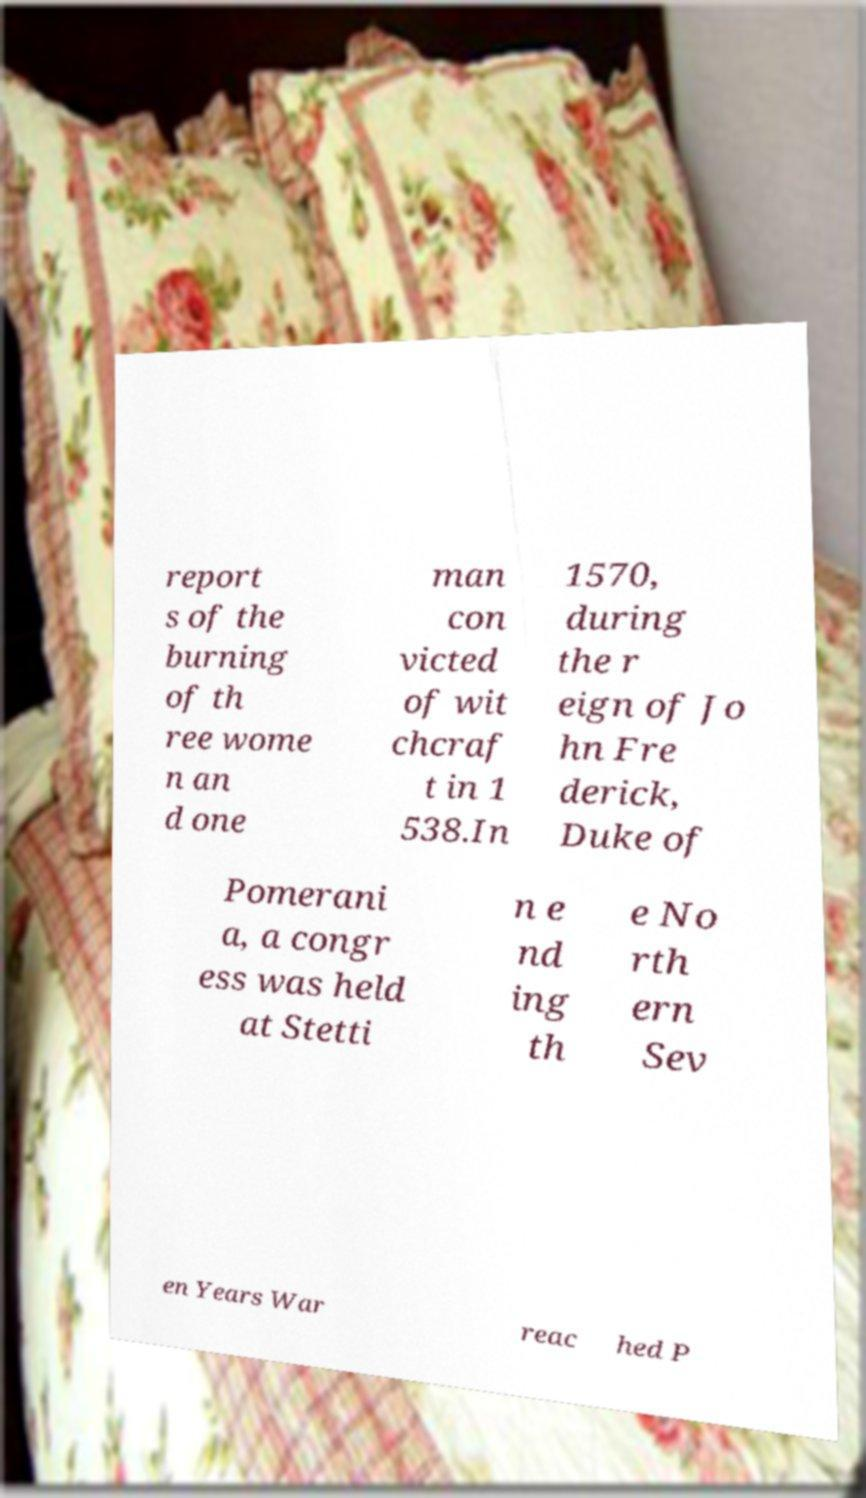For documentation purposes, I need the text within this image transcribed. Could you provide that? report s of the burning of th ree wome n an d one man con victed of wit chcraf t in 1 538.In 1570, during the r eign of Jo hn Fre derick, Duke of Pomerani a, a congr ess was held at Stetti n e nd ing th e No rth ern Sev en Years War reac hed P 